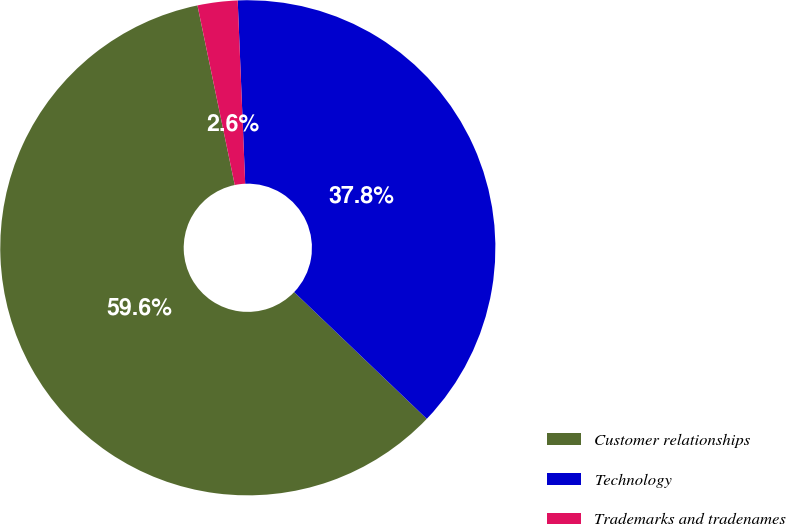Convert chart to OTSL. <chart><loc_0><loc_0><loc_500><loc_500><pie_chart><fcel>Customer relationships<fcel>Technology<fcel>Trademarks and tradenames<nl><fcel>59.6%<fcel>37.79%<fcel>2.61%<nl></chart> 